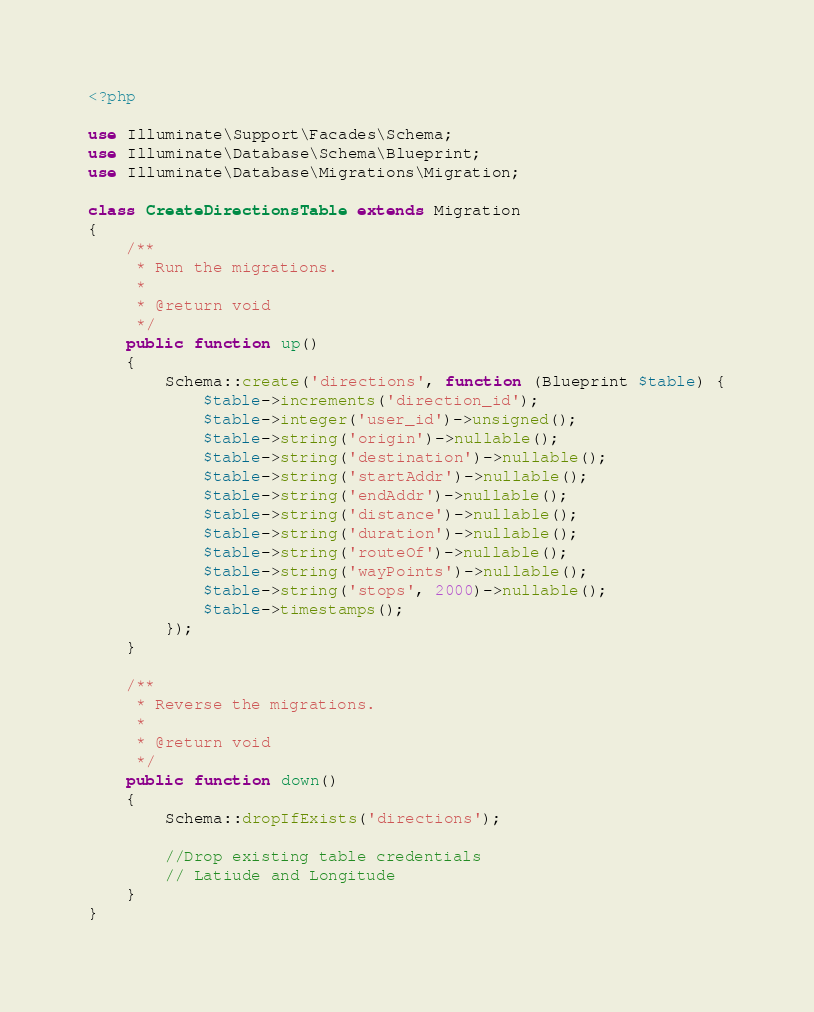<code> <loc_0><loc_0><loc_500><loc_500><_PHP_><?php

use Illuminate\Support\Facades\Schema;
use Illuminate\Database\Schema\Blueprint;
use Illuminate\Database\Migrations\Migration;

class CreateDirectionsTable extends Migration
{
    /**
     * Run the migrations.
     *
     * @return void
     */
    public function up()
    {
        Schema::create('directions', function (Blueprint $table) {
            $table->increments('direction_id');
            $table->integer('user_id')->unsigned();
            $table->string('origin')->nullable();
            $table->string('destination')->nullable();
            $table->string('startAddr')->nullable();
            $table->string('endAddr')->nullable();
            $table->string('distance')->nullable();
            $table->string('duration')->nullable();
            $table->string('routeOf')->nullable();
            $table->string('wayPoints')->nullable();
            $table->string('stops', 2000)->nullable();
            $table->timestamps();
        });
    }

    /**
     * Reverse the migrations.
     *
     * @return void
     */
    public function down()
    {
        Schema::dropIfExists('directions');

        //Drop existing table credentials
        // Latiude and Longitude
    }
}
</code> 